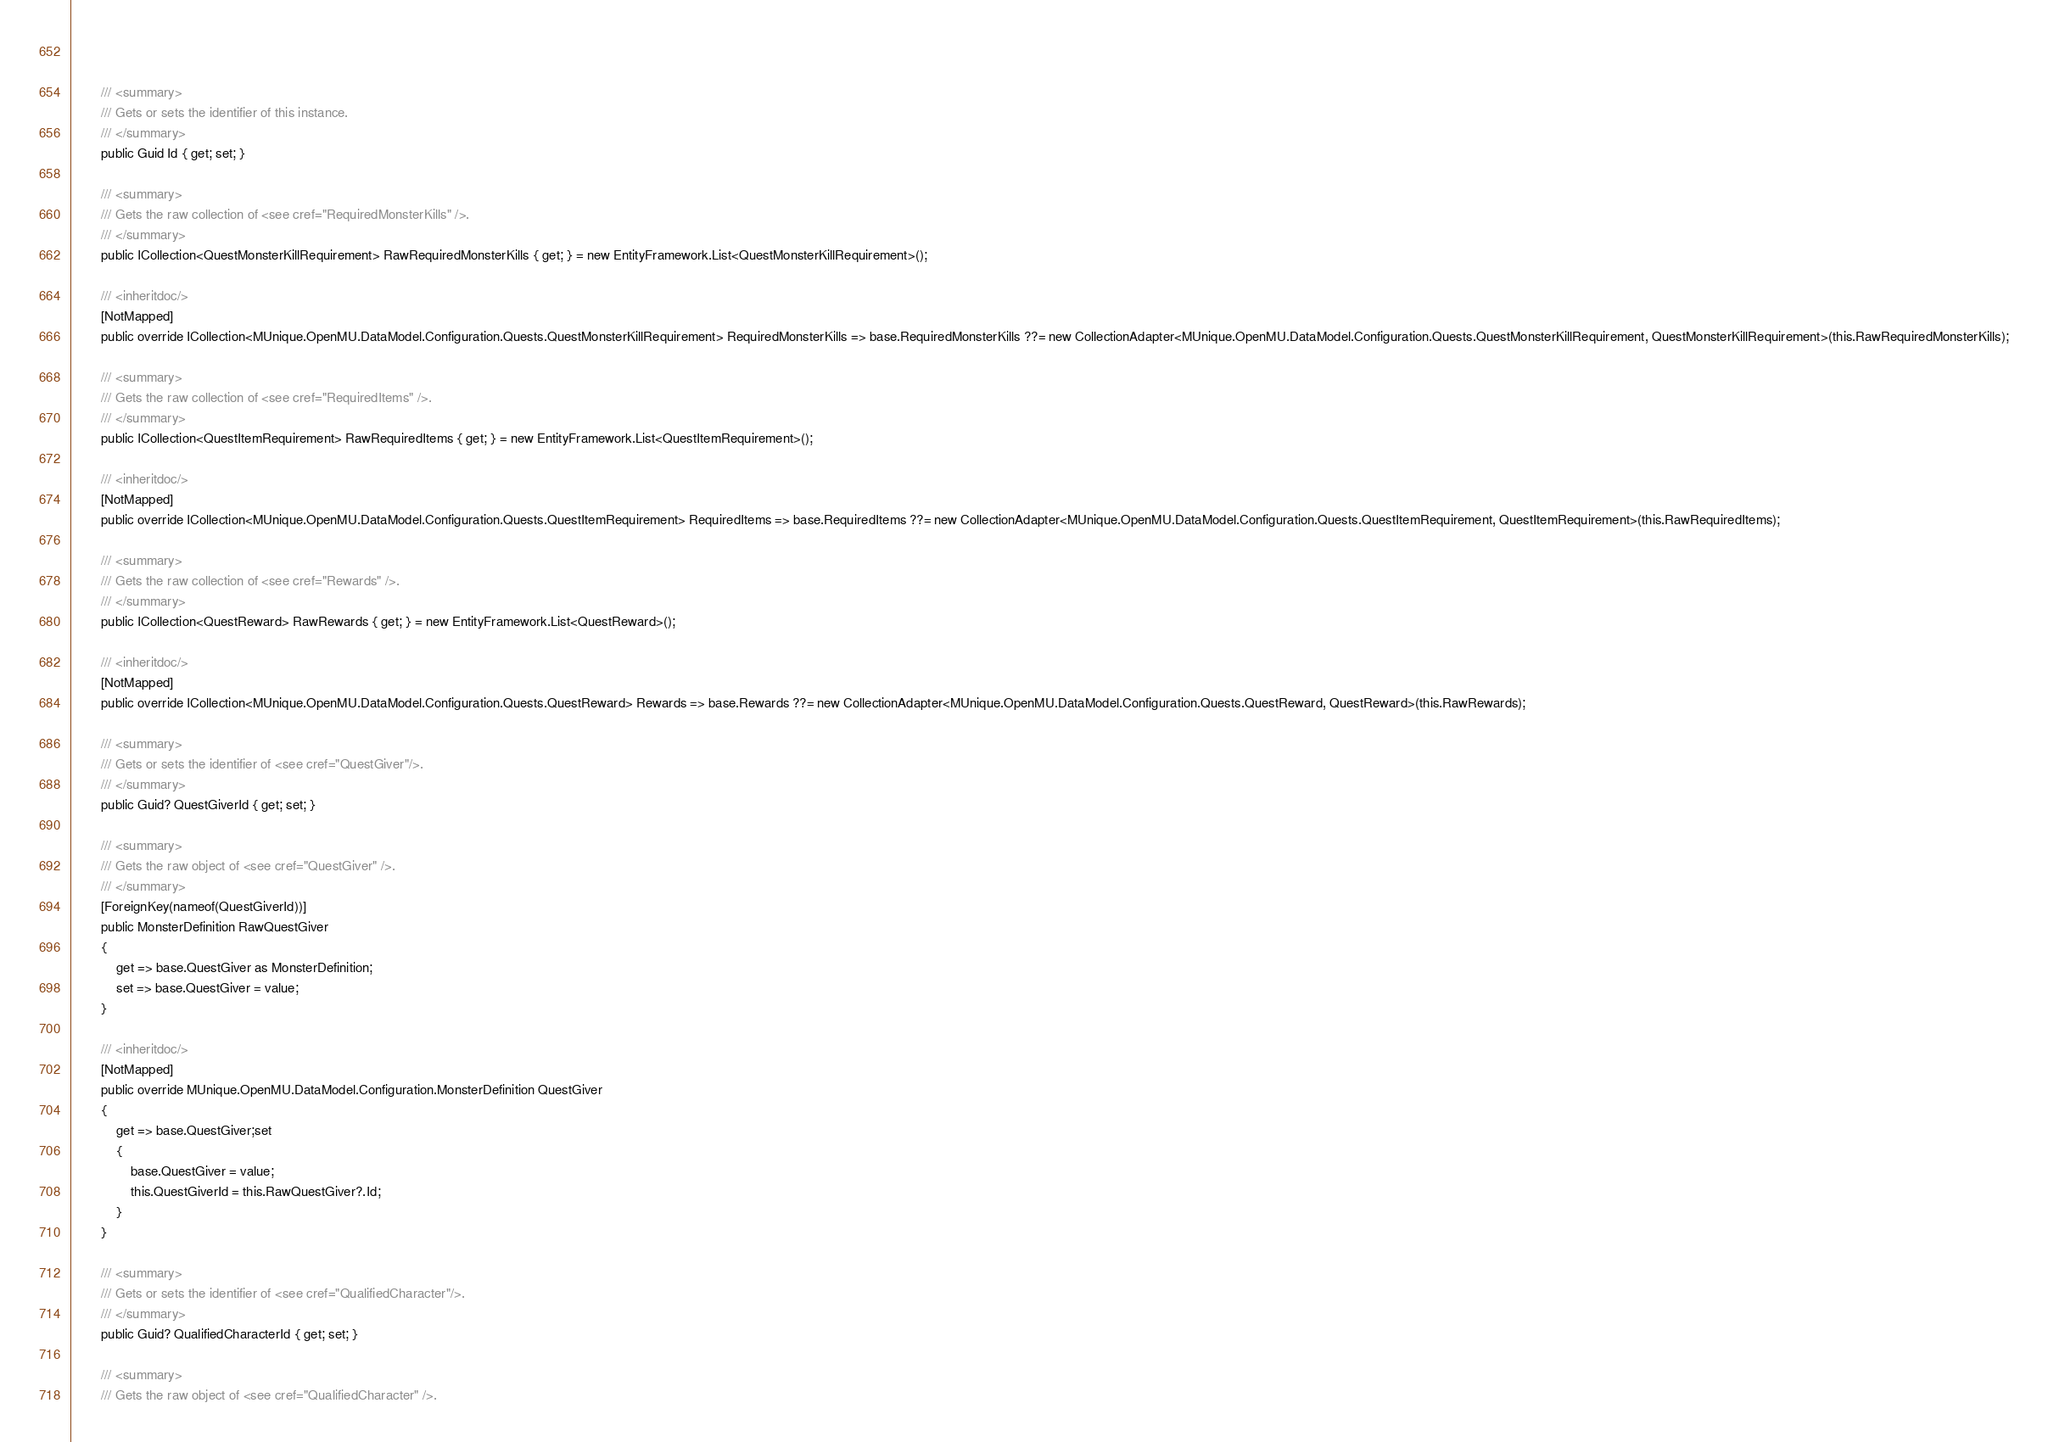Convert code to text. <code><loc_0><loc_0><loc_500><loc_500><_C#_>        
        
        /// <summary>
        /// Gets or sets the identifier of this instance.
        /// </summary>
        public Guid Id { get; set; }
        
        /// <summary>
        /// Gets the raw collection of <see cref="RequiredMonsterKills" />.
        /// </summary>
        public ICollection<QuestMonsterKillRequirement> RawRequiredMonsterKills { get; } = new EntityFramework.List<QuestMonsterKillRequirement>();
        
        /// <inheritdoc/>
        [NotMapped]
        public override ICollection<MUnique.OpenMU.DataModel.Configuration.Quests.QuestMonsterKillRequirement> RequiredMonsterKills => base.RequiredMonsterKills ??= new CollectionAdapter<MUnique.OpenMU.DataModel.Configuration.Quests.QuestMonsterKillRequirement, QuestMonsterKillRequirement>(this.RawRequiredMonsterKills);

        /// <summary>
        /// Gets the raw collection of <see cref="RequiredItems" />.
        /// </summary>
        public ICollection<QuestItemRequirement> RawRequiredItems { get; } = new EntityFramework.List<QuestItemRequirement>();
        
        /// <inheritdoc/>
        [NotMapped]
        public override ICollection<MUnique.OpenMU.DataModel.Configuration.Quests.QuestItemRequirement> RequiredItems => base.RequiredItems ??= new CollectionAdapter<MUnique.OpenMU.DataModel.Configuration.Quests.QuestItemRequirement, QuestItemRequirement>(this.RawRequiredItems);

        /// <summary>
        /// Gets the raw collection of <see cref="Rewards" />.
        /// </summary>
        public ICollection<QuestReward> RawRewards { get; } = new EntityFramework.List<QuestReward>();
        
        /// <inheritdoc/>
        [NotMapped]
        public override ICollection<MUnique.OpenMU.DataModel.Configuration.Quests.QuestReward> Rewards => base.Rewards ??= new CollectionAdapter<MUnique.OpenMU.DataModel.Configuration.Quests.QuestReward, QuestReward>(this.RawRewards);

        /// <summary>
        /// Gets or sets the identifier of <see cref="QuestGiver"/>.
        /// </summary>
        public Guid? QuestGiverId { get; set; }

        /// <summary>
        /// Gets the raw object of <see cref="QuestGiver" />.
        /// </summary>
        [ForeignKey(nameof(QuestGiverId))]
        public MonsterDefinition RawQuestGiver
        {
            get => base.QuestGiver as MonsterDefinition;
            set => base.QuestGiver = value;
        }

        /// <inheritdoc/>
        [NotMapped]
        public override MUnique.OpenMU.DataModel.Configuration.MonsterDefinition QuestGiver
        {
            get => base.QuestGiver;set
            {
                base.QuestGiver = value;
                this.QuestGiverId = this.RawQuestGiver?.Id;
            }
        }

        /// <summary>
        /// Gets or sets the identifier of <see cref="QualifiedCharacter"/>.
        /// </summary>
        public Guid? QualifiedCharacterId { get; set; }

        /// <summary>
        /// Gets the raw object of <see cref="QualifiedCharacter" />.</code> 